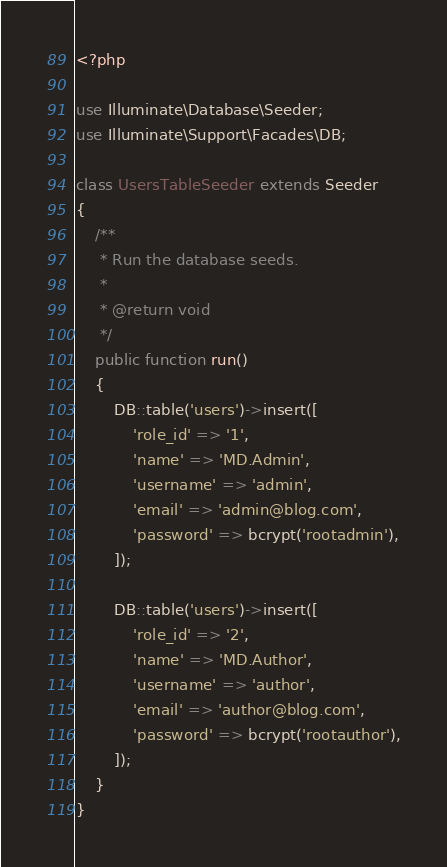Convert code to text. <code><loc_0><loc_0><loc_500><loc_500><_PHP_><?php

use Illuminate\Database\Seeder;
use Illuminate\Support\Facades\DB;

class UsersTableSeeder extends Seeder
{
    /**
     * Run the database seeds.
     *
     * @return void
     */
    public function run()
    {
        DB::table('users')->insert([
            'role_id' => '1',
            'name' => 'MD.Admin',
            'username' => 'admin',
            'email' => 'admin@blog.com',
            'password' => bcrypt('rootadmin'),
        ]);

        DB::table('users')->insert([
            'role_id' => '2',
            'name' => 'MD.Author',
            'username' => 'author',
            'email' => 'author@blog.com',
            'password' => bcrypt('rootauthor'),
        ]);
    }
}</code> 